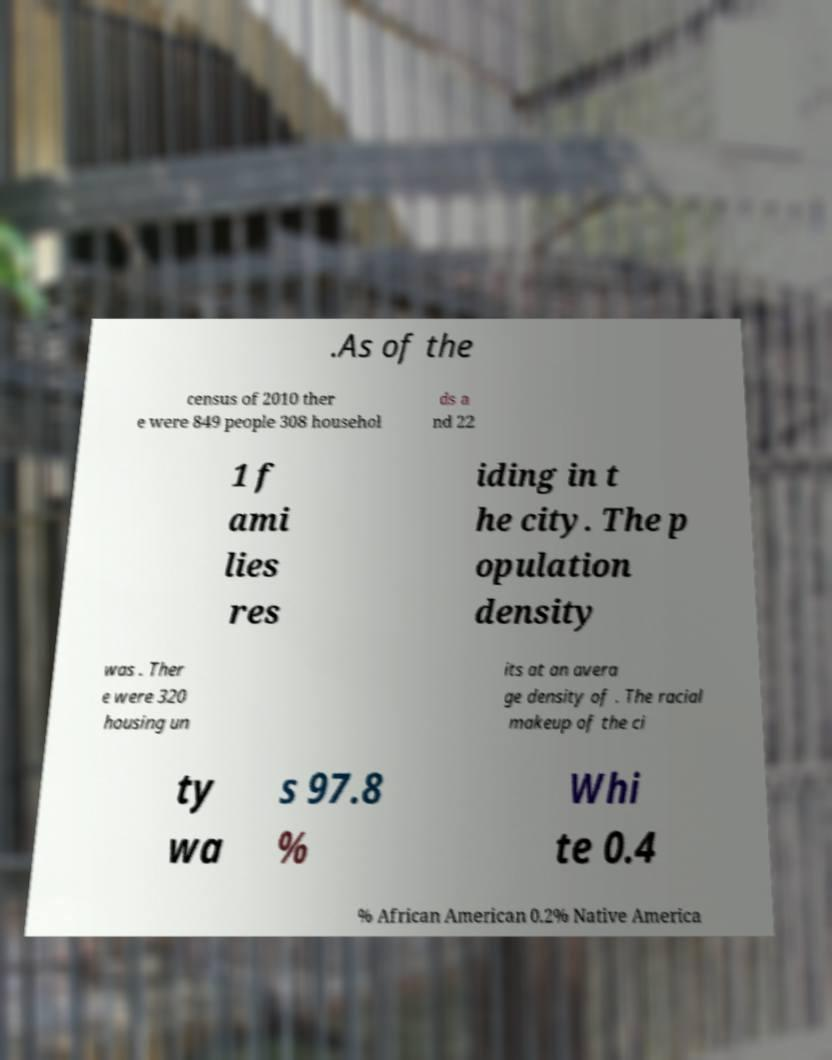Can you accurately transcribe the text from the provided image for me? .As of the census of 2010 ther e were 849 people 308 househol ds a nd 22 1 f ami lies res iding in t he city. The p opulation density was . Ther e were 320 housing un its at an avera ge density of . The racial makeup of the ci ty wa s 97.8 % Whi te 0.4 % African American 0.2% Native America 